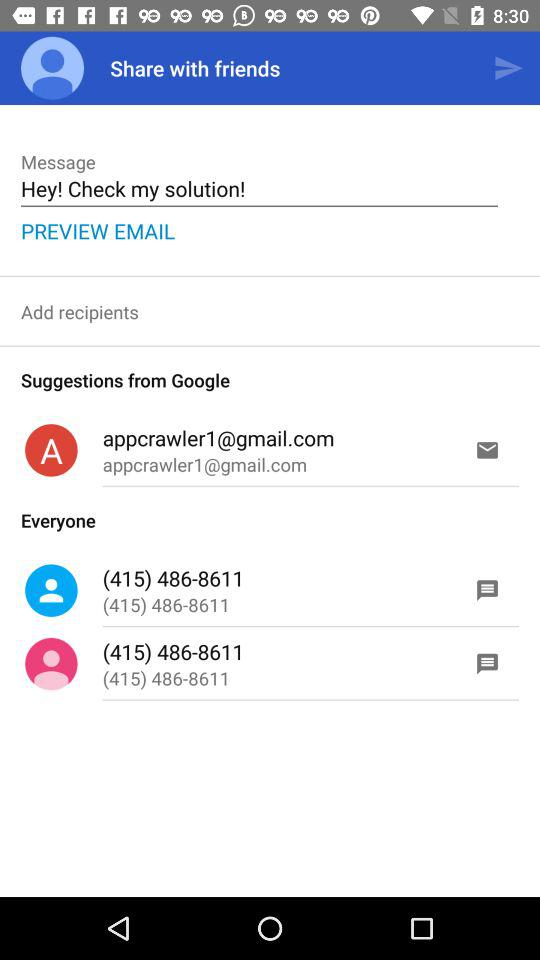Which phone number is mentioned in "Everyone"? The mentioned phone number in "Everyone" is (415) 486-8611. 